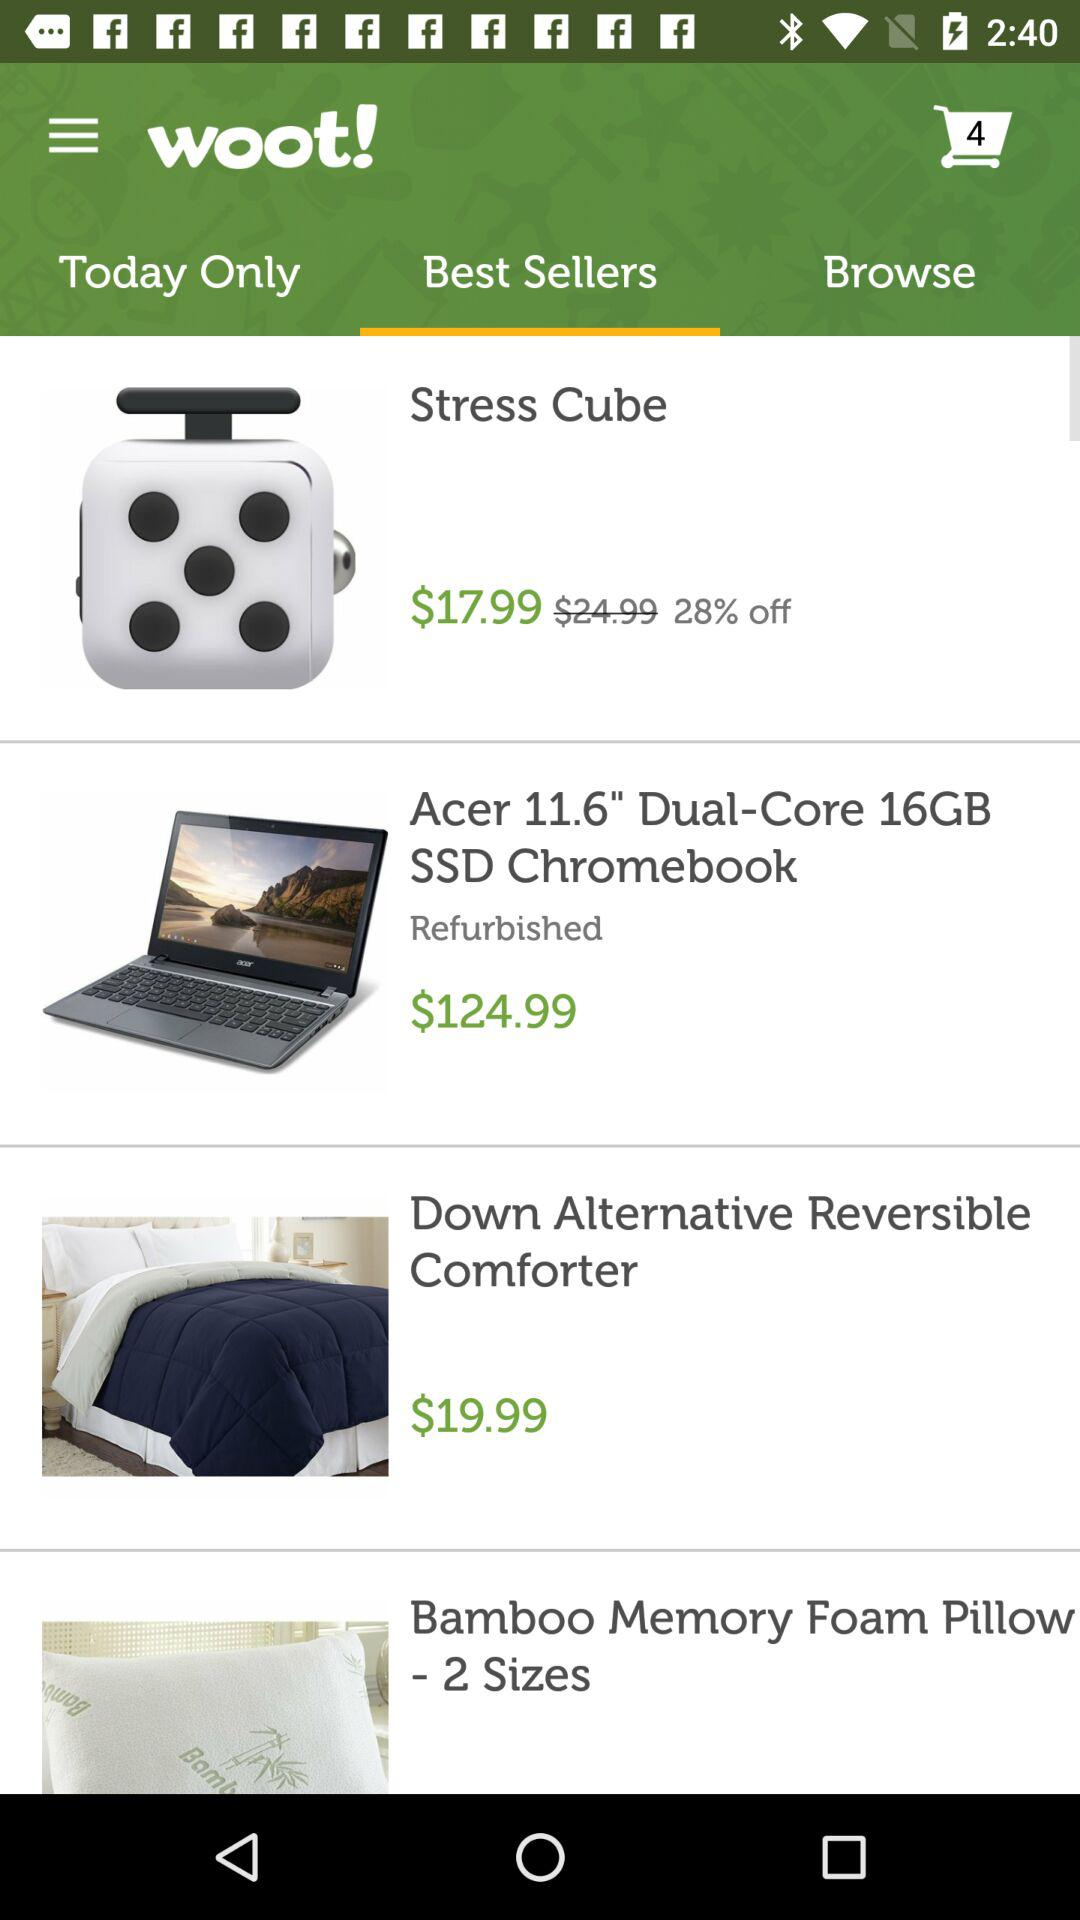What is the number of items in a shopping cart? There are 4 items in the shopping cart. 